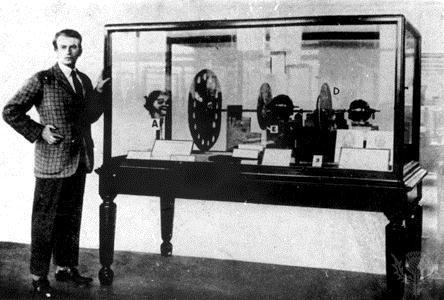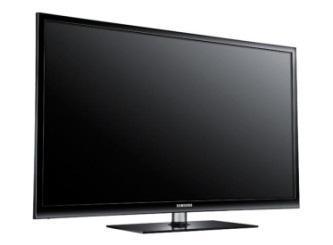The first image is the image on the left, the second image is the image on the right. Evaluate the accuracy of this statement regarding the images: "The right image contains one flat screen television that is turned off.". Is it true? Answer yes or no. Yes. 